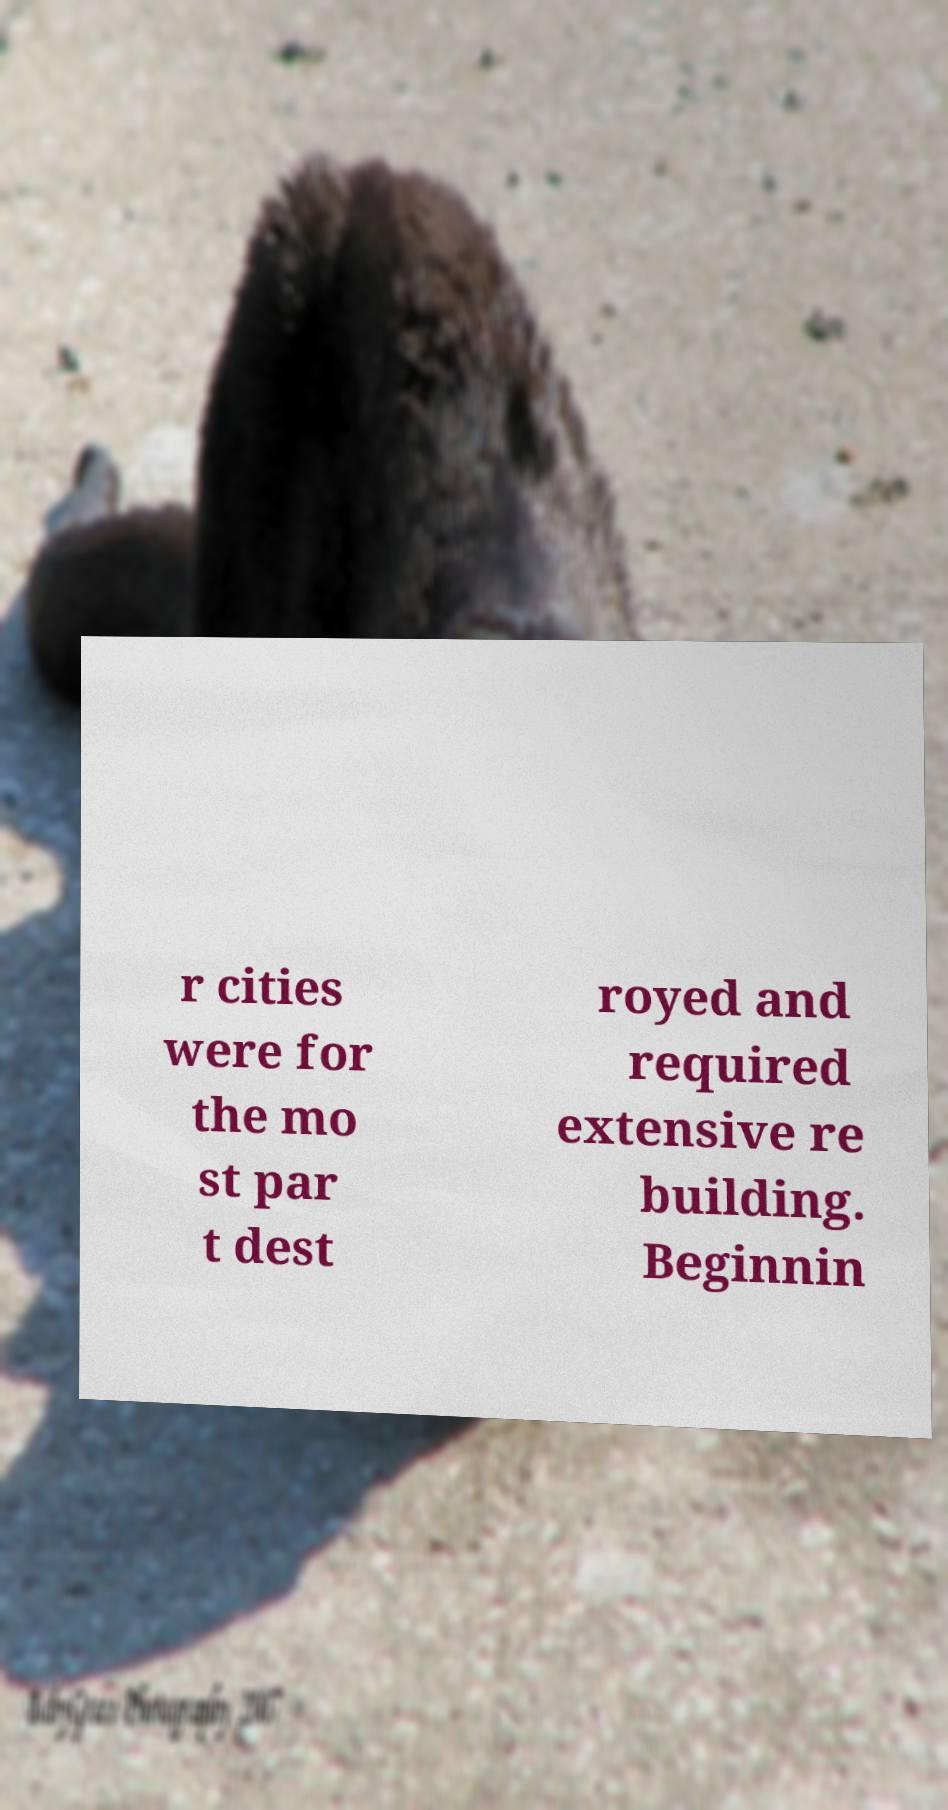Please read and relay the text visible in this image. What does it say? r cities were for the mo st par t dest royed and required extensive re building. Beginnin 